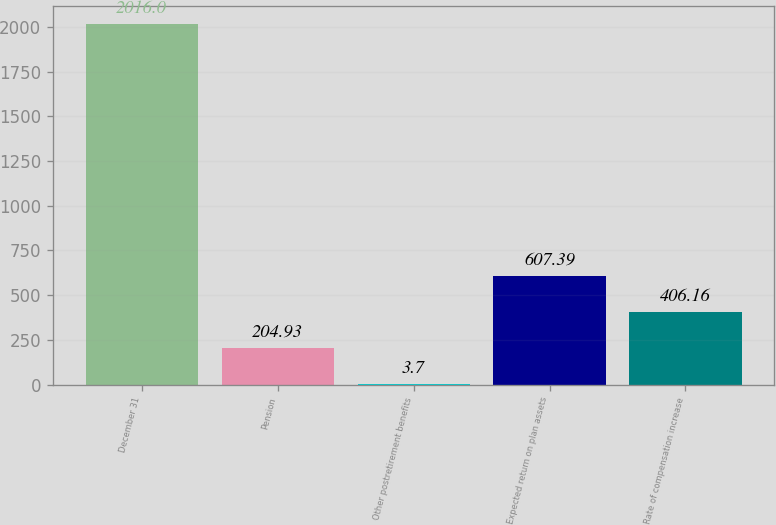<chart> <loc_0><loc_0><loc_500><loc_500><bar_chart><fcel>December 31<fcel>Pension<fcel>Other postretirement benefits<fcel>Expected return on plan assets<fcel>Rate of compensation increase<nl><fcel>2016<fcel>204.93<fcel>3.7<fcel>607.39<fcel>406.16<nl></chart> 